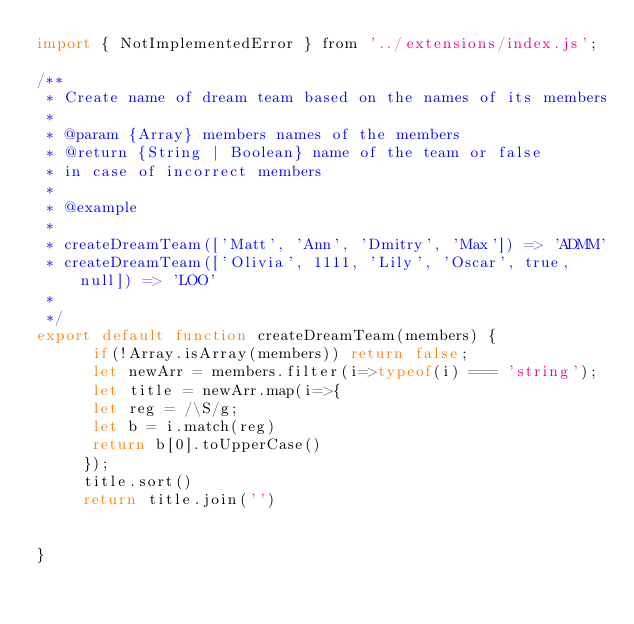Convert code to text. <code><loc_0><loc_0><loc_500><loc_500><_JavaScript_>import { NotImplementedError } from '../extensions/index.js';

/**
 * Create name of dream team based on the names of its members
 *  
 * @param {Array} members names of the members 
 * @return {String | Boolean} name of the team or false
 * in case of incorrect members
 *
 * @example
 * 
 * createDreamTeam(['Matt', 'Ann', 'Dmitry', 'Max']) => 'ADMM'
 * createDreamTeam(['Olivia', 1111, 'Lily', 'Oscar', true, null]) => 'LOO'
 *
 */
export default function createDreamTeam(members) {
      if(!Array.isArray(members)) return false;
      let newArr = members.filter(i=>typeof(i) === 'string');
      let title = newArr.map(i=>{
      let reg = /\S/g;
      let b = i.match(reg)
      return b[0].toUpperCase()
     });
     title.sort()
     return title.join('')
    
  
}


</code> 